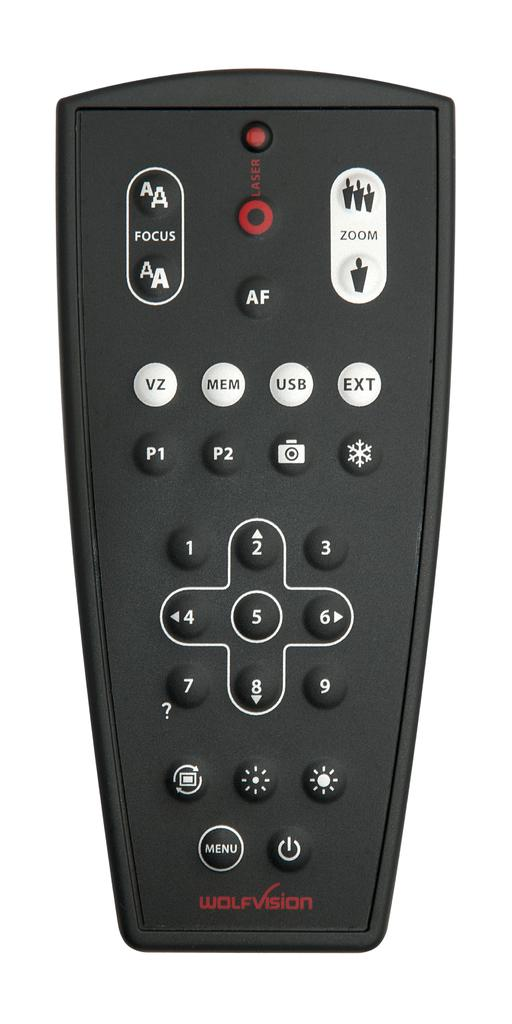<image>
Render a clear and concise summary of the photo. A remote made by the company wolf vision. 